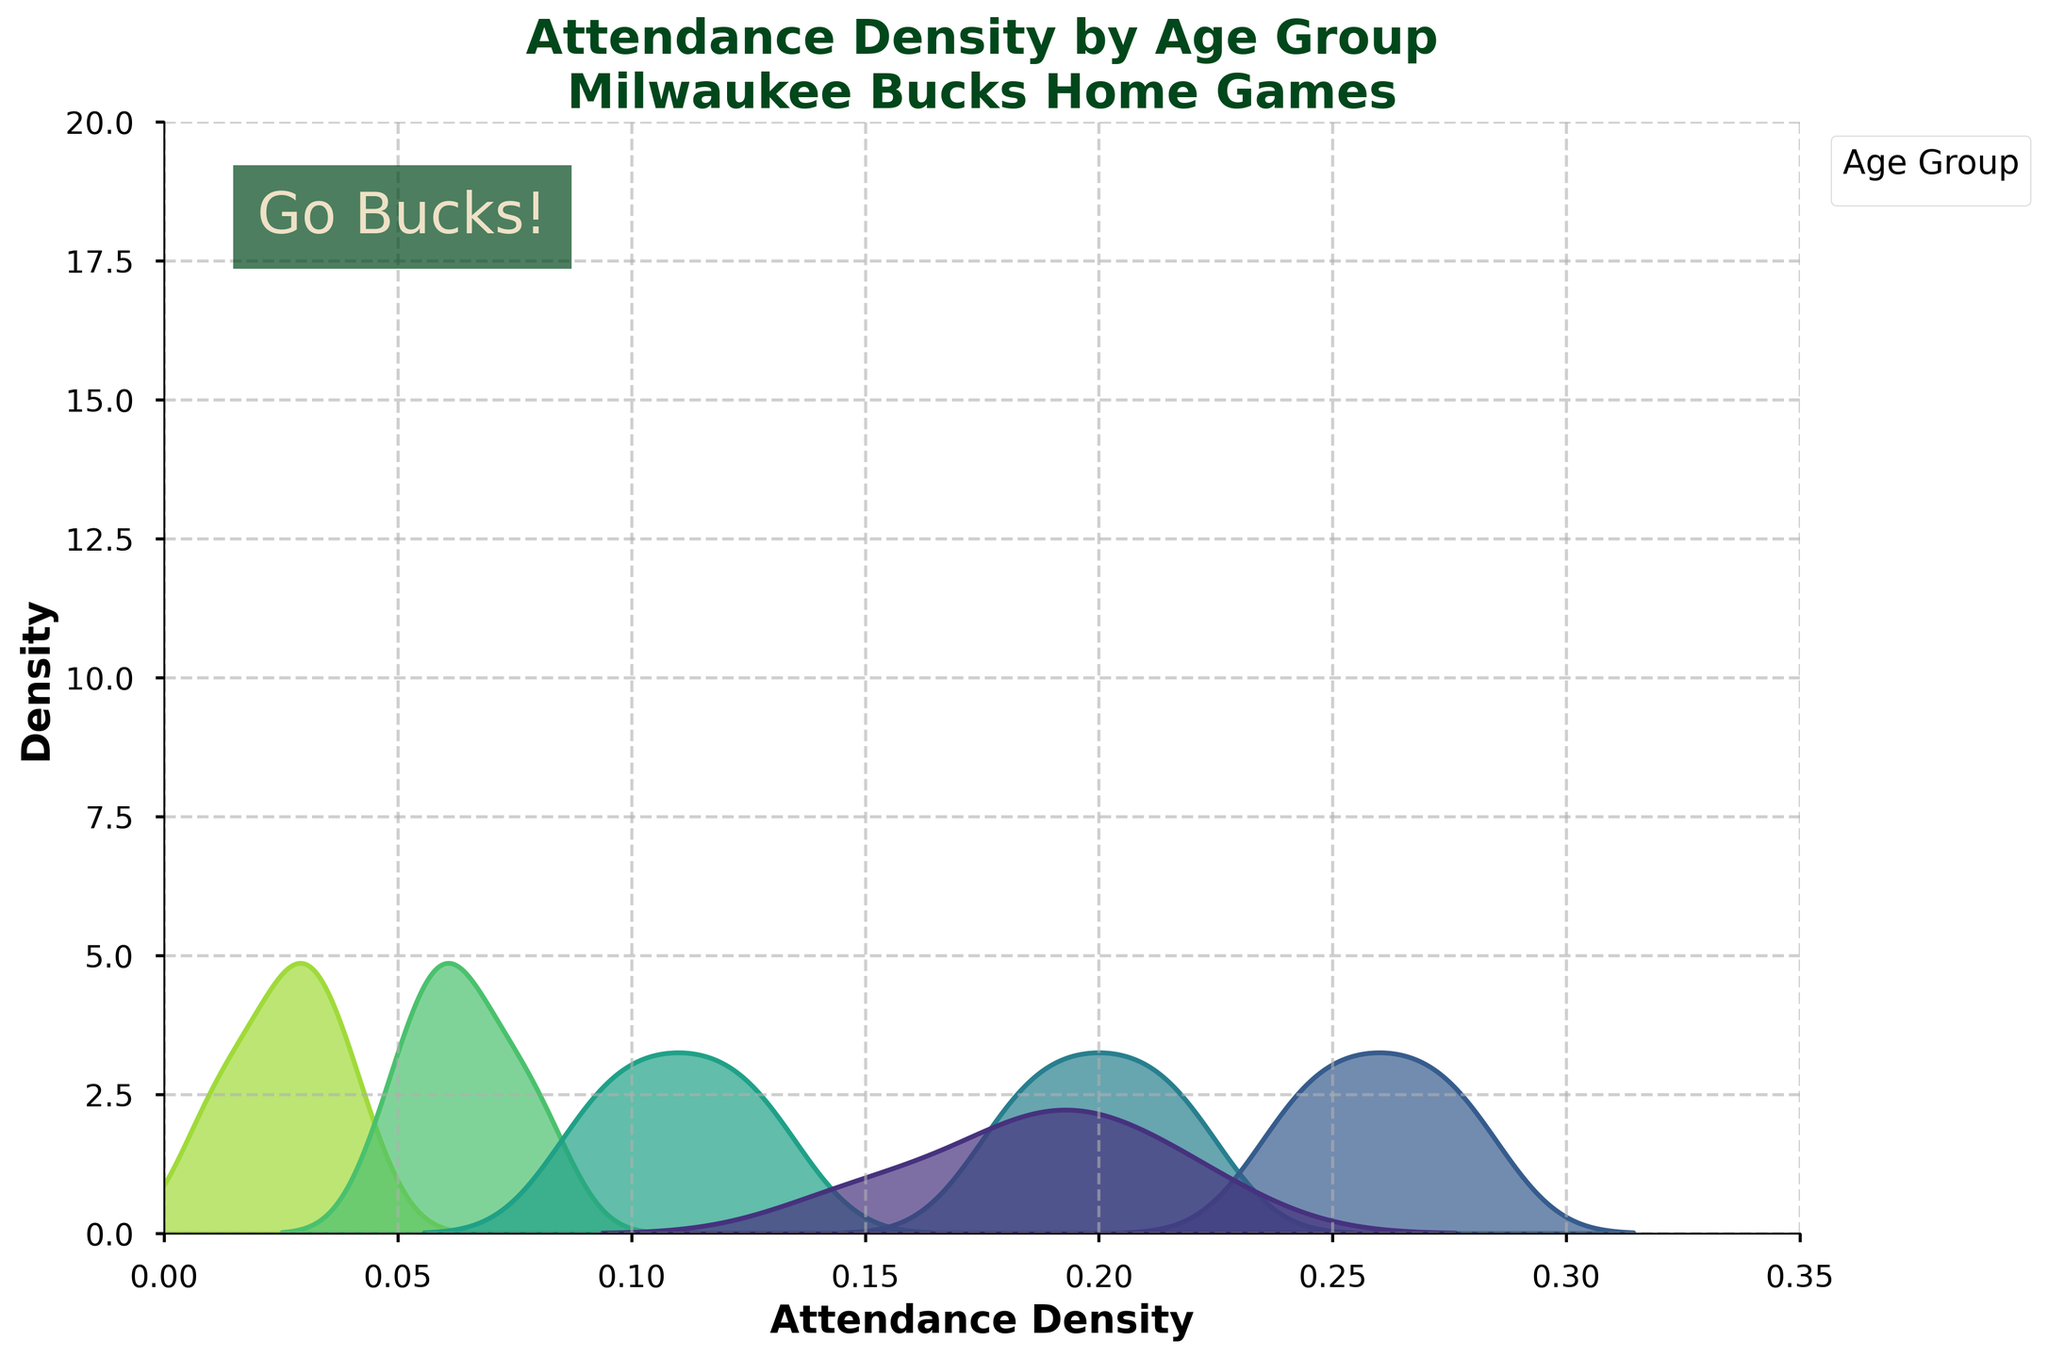What is the title of the figure? The title is usually located at the top of the figure. In this case, it reads, "Attendance Density by Age Group\nMilwaukee Bucks Home Games".
Answer: Attendance Density by Age Group\nMilwaukee Bucks Home Games Which age group has the highest attendance density peak? Observing the peaks of the density plots, the highest peak corresponds to the 26-35 age group.
Answer: 26-35 What is the range of the x-axis? The x-axis range is determined by the xlim function, which sets it from 0 to 0.35.
Answer: 0 to 0.35 Which age group shows the lowest attendance density peak? By comparing the lowest peaks, the age group 66+ has the lowest density peak.
Answer: 66+ What's the difference between the highest and lowest attendance density peaks? The highest peak is for the 26-35 age group and looks around 18, while the lowest is for the 66+ age group which appears around 2. So, the difference is 18 - 2 = 16.
Answer: 16 Do all age groups show attendance densities above 0.15 on the x-axis? Observing the density plots along the x-axis, groups like 56-65 and 66+ do not show densities above 0.15, indicating that not all age groups reach this value.
Answer: No Which age group has an attendance density peak closest to 0.20? The 18-25 and 36-45 age groups have peaks near 0.20, but the 18-25 age group is closest to this value.
Answer: 18-25 What colors are used for the density plots? The color palette 'viridis' is used, typically involving shades ranging from dark blue to yellow.
Answer: shades from dark blue to yellow How are the density plots shaded? The shade parameter is set to True, meaning the plots are filled with color under the curves.
Answer: Filled with color Do any age groups have overlapping density peaks? Observing the density plots, the age groups 18-25 and 36-45 have peaks that are very close and can be considered overlapping around the 0.20 value on the x-axis.
Answer: Yes 